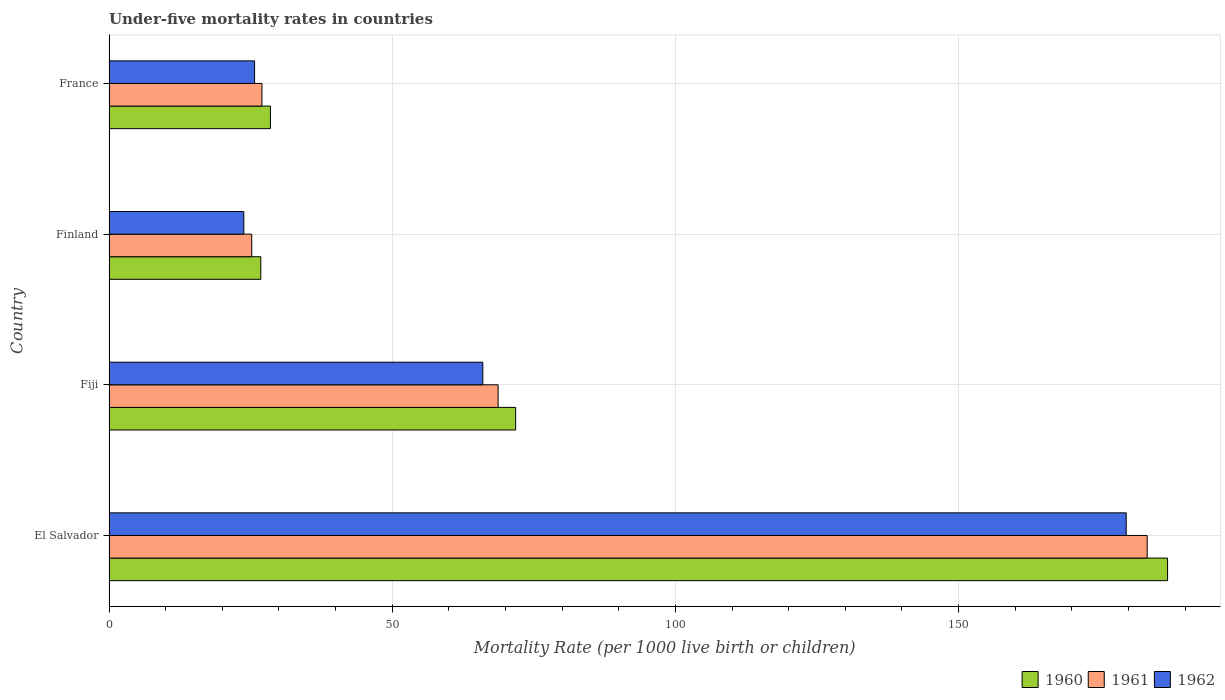How many different coloured bars are there?
Provide a short and direct response. 3. How many groups of bars are there?
Make the answer very short. 4. Are the number of bars per tick equal to the number of legend labels?
Make the answer very short. Yes. Are the number of bars on each tick of the Y-axis equal?
Provide a succinct answer. Yes. How many bars are there on the 3rd tick from the top?
Offer a terse response. 3. What is the label of the 3rd group of bars from the top?
Your response must be concise. Fiji. In how many cases, is the number of bars for a given country not equal to the number of legend labels?
Ensure brevity in your answer.  0. What is the under-five mortality rate in 1962 in France?
Ensure brevity in your answer.  25.7. Across all countries, what is the maximum under-five mortality rate in 1961?
Provide a short and direct response. 183.3. Across all countries, what is the minimum under-five mortality rate in 1961?
Offer a very short reply. 25.2. In which country was the under-five mortality rate in 1961 maximum?
Provide a succinct answer. El Salvador. In which country was the under-five mortality rate in 1960 minimum?
Provide a short and direct response. Finland. What is the total under-five mortality rate in 1961 in the graph?
Provide a succinct answer. 304.2. What is the difference between the under-five mortality rate in 1962 in Fiji and that in France?
Make the answer very short. 40.3. What is the average under-five mortality rate in 1961 per country?
Provide a short and direct response. 76.05. What is the ratio of the under-five mortality rate in 1962 in El Salvador to that in Finland?
Keep it short and to the point. 7.55. Is the under-five mortality rate in 1962 in Fiji less than that in Finland?
Make the answer very short. No. What is the difference between the highest and the second highest under-five mortality rate in 1962?
Offer a terse response. 113.6. What is the difference between the highest and the lowest under-five mortality rate in 1960?
Your answer should be compact. 160.1. In how many countries, is the under-five mortality rate in 1960 greater than the average under-five mortality rate in 1960 taken over all countries?
Offer a very short reply. 1. Is the sum of the under-five mortality rate in 1961 in El Salvador and Finland greater than the maximum under-five mortality rate in 1960 across all countries?
Your response must be concise. Yes. What does the 3rd bar from the top in Fiji represents?
Offer a very short reply. 1960. What is the difference between two consecutive major ticks on the X-axis?
Offer a very short reply. 50. Are the values on the major ticks of X-axis written in scientific E-notation?
Your answer should be compact. No. Does the graph contain grids?
Keep it short and to the point. Yes. How many legend labels are there?
Your response must be concise. 3. How are the legend labels stacked?
Your answer should be very brief. Horizontal. What is the title of the graph?
Provide a short and direct response. Under-five mortality rates in countries. What is the label or title of the X-axis?
Provide a succinct answer. Mortality Rate (per 1000 live birth or children). What is the label or title of the Y-axis?
Make the answer very short. Country. What is the Mortality Rate (per 1000 live birth or children) of 1960 in El Salvador?
Ensure brevity in your answer.  186.9. What is the Mortality Rate (per 1000 live birth or children) in 1961 in El Salvador?
Provide a succinct answer. 183.3. What is the Mortality Rate (per 1000 live birth or children) of 1962 in El Salvador?
Your answer should be compact. 179.6. What is the Mortality Rate (per 1000 live birth or children) of 1960 in Fiji?
Your answer should be compact. 71.8. What is the Mortality Rate (per 1000 live birth or children) in 1961 in Fiji?
Your response must be concise. 68.7. What is the Mortality Rate (per 1000 live birth or children) in 1960 in Finland?
Give a very brief answer. 26.8. What is the Mortality Rate (per 1000 live birth or children) of 1961 in Finland?
Keep it short and to the point. 25.2. What is the Mortality Rate (per 1000 live birth or children) in 1962 in Finland?
Give a very brief answer. 23.8. What is the Mortality Rate (per 1000 live birth or children) in 1962 in France?
Offer a terse response. 25.7. Across all countries, what is the maximum Mortality Rate (per 1000 live birth or children) in 1960?
Offer a terse response. 186.9. Across all countries, what is the maximum Mortality Rate (per 1000 live birth or children) of 1961?
Your answer should be compact. 183.3. Across all countries, what is the maximum Mortality Rate (per 1000 live birth or children) of 1962?
Offer a terse response. 179.6. Across all countries, what is the minimum Mortality Rate (per 1000 live birth or children) in 1960?
Give a very brief answer. 26.8. Across all countries, what is the minimum Mortality Rate (per 1000 live birth or children) of 1961?
Keep it short and to the point. 25.2. Across all countries, what is the minimum Mortality Rate (per 1000 live birth or children) of 1962?
Provide a short and direct response. 23.8. What is the total Mortality Rate (per 1000 live birth or children) of 1960 in the graph?
Provide a succinct answer. 314. What is the total Mortality Rate (per 1000 live birth or children) of 1961 in the graph?
Your response must be concise. 304.2. What is the total Mortality Rate (per 1000 live birth or children) in 1962 in the graph?
Make the answer very short. 295.1. What is the difference between the Mortality Rate (per 1000 live birth or children) of 1960 in El Salvador and that in Fiji?
Your answer should be very brief. 115.1. What is the difference between the Mortality Rate (per 1000 live birth or children) of 1961 in El Salvador and that in Fiji?
Make the answer very short. 114.6. What is the difference between the Mortality Rate (per 1000 live birth or children) in 1962 in El Salvador and that in Fiji?
Your answer should be very brief. 113.6. What is the difference between the Mortality Rate (per 1000 live birth or children) of 1960 in El Salvador and that in Finland?
Provide a short and direct response. 160.1. What is the difference between the Mortality Rate (per 1000 live birth or children) of 1961 in El Salvador and that in Finland?
Ensure brevity in your answer.  158.1. What is the difference between the Mortality Rate (per 1000 live birth or children) of 1962 in El Salvador and that in Finland?
Make the answer very short. 155.8. What is the difference between the Mortality Rate (per 1000 live birth or children) of 1960 in El Salvador and that in France?
Provide a succinct answer. 158.4. What is the difference between the Mortality Rate (per 1000 live birth or children) of 1961 in El Salvador and that in France?
Your response must be concise. 156.3. What is the difference between the Mortality Rate (per 1000 live birth or children) of 1962 in El Salvador and that in France?
Your answer should be compact. 153.9. What is the difference between the Mortality Rate (per 1000 live birth or children) of 1960 in Fiji and that in Finland?
Give a very brief answer. 45. What is the difference between the Mortality Rate (per 1000 live birth or children) in 1961 in Fiji and that in Finland?
Your answer should be very brief. 43.5. What is the difference between the Mortality Rate (per 1000 live birth or children) of 1962 in Fiji and that in Finland?
Provide a succinct answer. 42.2. What is the difference between the Mortality Rate (per 1000 live birth or children) in 1960 in Fiji and that in France?
Offer a very short reply. 43.3. What is the difference between the Mortality Rate (per 1000 live birth or children) in 1961 in Fiji and that in France?
Offer a very short reply. 41.7. What is the difference between the Mortality Rate (per 1000 live birth or children) of 1962 in Fiji and that in France?
Ensure brevity in your answer.  40.3. What is the difference between the Mortality Rate (per 1000 live birth or children) of 1960 in Finland and that in France?
Offer a very short reply. -1.7. What is the difference between the Mortality Rate (per 1000 live birth or children) in 1960 in El Salvador and the Mortality Rate (per 1000 live birth or children) in 1961 in Fiji?
Provide a short and direct response. 118.2. What is the difference between the Mortality Rate (per 1000 live birth or children) in 1960 in El Salvador and the Mortality Rate (per 1000 live birth or children) in 1962 in Fiji?
Offer a very short reply. 120.9. What is the difference between the Mortality Rate (per 1000 live birth or children) of 1961 in El Salvador and the Mortality Rate (per 1000 live birth or children) of 1962 in Fiji?
Offer a terse response. 117.3. What is the difference between the Mortality Rate (per 1000 live birth or children) of 1960 in El Salvador and the Mortality Rate (per 1000 live birth or children) of 1961 in Finland?
Offer a terse response. 161.7. What is the difference between the Mortality Rate (per 1000 live birth or children) in 1960 in El Salvador and the Mortality Rate (per 1000 live birth or children) in 1962 in Finland?
Your answer should be compact. 163.1. What is the difference between the Mortality Rate (per 1000 live birth or children) in 1961 in El Salvador and the Mortality Rate (per 1000 live birth or children) in 1962 in Finland?
Your answer should be very brief. 159.5. What is the difference between the Mortality Rate (per 1000 live birth or children) of 1960 in El Salvador and the Mortality Rate (per 1000 live birth or children) of 1961 in France?
Provide a succinct answer. 159.9. What is the difference between the Mortality Rate (per 1000 live birth or children) in 1960 in El Salvador and the Mortality Rate (per 1000 live birth or children) in 1962 in France?
Offer a terse response. 161.2. What is the difference between the Mortality Rate (per 1000 live birth or children) of 1961 in El Salvador and the Mortality Rate (per 1000 live birth or children) of 1962 in France?
Give a very brief answer. 157.6. What is the difference between the Mortality Rate (per 1000 live birth or children) of 1960 in Fiji and the Mortality Rate (per 1000 live birth or children) of 1961 in Finland?
Provide a short and direct response. 46.6. What is the difference between the Mortality Rate (per 1000 live birth or children) in 1961 in Fiji and the Mortality Rate (per 1000 live birth or children) in 1962 in Finland?
Your answer should be compact. 44.9. What is the difference between the Mortality Rate (per 1000 live birth or children) in 1960 in Fiji and the Mortality Rate (per 1000 live birth or children) in 1961 in France?
Give a very brief answer. 44.8. What is the difference between the Mortality Rate (per 1000 live birth or children) in 1960 in Fiji and the Mortality Rate (per 1000 live birth or children) in 1962 in France?
Keep it short and to the point. 46.1. What is the difference between the Mortality Rate (per 1000 live birth or children) in 1961 in Fiji and the Mortality Rate (per 1000 live birth or children) in 1962 in France?
Ensure brevity in your answer.  43. What is the difference between the Mortality Rate (per 1000 live birth or children) of 1960 in Finland and the Mortality Rate (per 1000 live birth or children) of 1962 in France?
Provide a short and direct response. 1.1. What is the difference between the Mortality Rate (per 1000 live birth or children) in 1961 in Finland and the Mortality Rate (per 1000 live birth or children) in 1962 in France?
Provide a short and direct response. -0.5. What is the average Mortality Rate (per 1000 live birth or children) in 1960 per country?
Ensure brevity in your answer.  78.5. What is the average Mortality Rate (per 1000 live birth or children) in 1961 per country?
Offer a very short reply. 76.05. What is the average Mortality Rate (per 1000 live birth or children) in 1962 per country?
Offer a terse response. 73.78. What is the difference between the Mortality Rate (per 1000 live birth or children) of 1960 and Mortality Rate (per 1000 live birth or children) of 1961 in El Salvador?
Your response must be concise. 3.6. What is the difference between the Mortality Rate (per 1000 live birth or children) in 1960 and Mortality Rate (per 1000 live birth or children) in 1962 in El Salvador?
Your response must be concise. 7.3. What is the difference between the Mortality Rate (per 1000 live birth or children) in 1961 and Mortality Rate (per 1000 live birth or children) in 1962 in El Salvador?
Offer a very short reply. 3.7. What is the difference between the Mortality Rate (per 1000 live birth or children) of 1960 and Mortality Rate (per 1000 live birth or children) of 1961 in Fiji?
Provide a short and direct response. 3.1. What is the difference between the Mortality Rate (per 1000 live birth or children) of 1960 and Mortality Rate (per 1000 live birth or children) of 1962 in Fiji?
Your answer should be compact. 5.8. What is the difference between the Mortality Rate (per 1000 live birth or children) in 1961 and Mortality Rate (per 1000 live birth or children) in 1962 in Fiji?
Provide a succinct answer. 2.7. What is the difference between the Mortality Rate (per 1000 live birth or children) in 1960 and Mortality Rate (per 1000 live birth or children) in 1962 in France?
Make the answer very short. 2.8. What is the difference between the Mortality Rate (per 1000 live birth or children) in 1961 and Mortality Rate (per 1000 live birth or children) in 1962 in France?
Offer a very short reply. 1.3. What is the ratio of the Mortality Rate (per 1000 live birth or children) of 1960 in El Salvador to that in Fiji?
Ensure brevity in your answer.  2.6. What is the ratio of the Mortality Rate (per 1000 live birth or children) in 1961 in El Salvador to that in Fiji?
Offer a terse response. 2.67. What is the ratio of the Mortality Rate (per 1000 live birth or children) of 1962 in El Salvador to that in Fiji?
Your response must be concise. 2.72. What is the ratio of the Mortality Rate (per 1000 live birth or children) in 1960 in El Salvador to that in Finland?
Offer a terse response. 6.97. What is the ratio of the Mortality Rate (per 1000 live birth or children) in 1961 in El Salvador to that in Finland?
Keep it short and to the point. 7.27. What is the ratio of the Mortality Rate (per 1000 live birth or children) of 1962 in El Salvador to that in Finland?
Offer a terse response. 7.55. What is the ratio of the Mortality Rate (per 1000 live birth or children) of 1960 in El Salvador to that in France?
Provide a succinct answer. 6.56. What is the ratio of the Mortality Rate (per 1000 live birth or children) in 1961 in El Salvador to that in France?
Provide a succinct answer. 6.79. What is the ratio of the Mortality Rate (per 1000 live birth or children) in 1962 in El Salvador to that in France?
Ensure brevity in your answer.  6.99. What is the ratio of the Mortality Rate (per 1000 live birth or children) in 1960 in Fiji to that in Finland?
Give a very brief answer. 2.68. What is the ratio of the Mortality Rate (per 1000 live birth or children) of 1961 in Fiji to that in Finland?
Provide a short and direct response. 2.73. What is the ratio of the Mortality Rate (per 1000 live birth or children) of 1962 in Fiji to that in Finland?
Ensure brevity in your answer.  2.77. What is the ratio of the Mortality Rate (per 1000 live birth or children) in 1960 in Fiji to that in France?
Your response must be concise. 2.52. What is the ratio of the Mortality Rate (per 1000 live birth or children) in 1961 in Fiji to that in France?
Provide a succinct answer. 2.54. What is the ratio of the Mortality Rate (per 1000 live birth or children) in 1962 in Fiji to that in France?
Provide a succinct answer. 2.57. What is the ratio of the Mortality Rate (per 1000 live birth or children) in 1960 in Finland to that in France?
Your answer should be compact. 0.94. What is the ratio of the Mortality Rate (per 1000 live birth or children) of 1962 in Finland to that in France?
Your response must be concise. 0.93. What is the difference between the highest and the second highest Mortality Rate (per 1000 live birth or children) in 1960?
Make the answer very short. 115.1. What is the difference between the highest and the second highest Mortality Rate (per 1000 live birth or children) of 1961?
Offer a very short reply. 114.6. What is the difference between the highest and the second highest Mortality Rate (per 1000 live birth or children) in 1962?
Your response must be concise. 113.6. What is the difference between the highest and the lowest Mortality Rate (per 1000 live birth or children) of 1960?
Your answer should be very brief. 160.1. What is the difference between the highest and the lowest Mortality Rate (per 1000 live birth or children) of 1961?
Give a very brief answer. 158.1. What is the difference between the highest and the lowest Mortality Rate (per 1000 live birth or children) in 1962?
Provide a short and direct response. 155.8. 